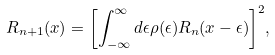<formula> <loc_0><loc_0><loc_500><loc_500>R _ { n + 1 } ( x ) = { \left [ \int _ { - \infty } ^ { \infty } d \epsilon \rho ( \epsilon ) R _ { n } ( x - \epsilon ) \right ] } ^ { 2 } ,</formula> 